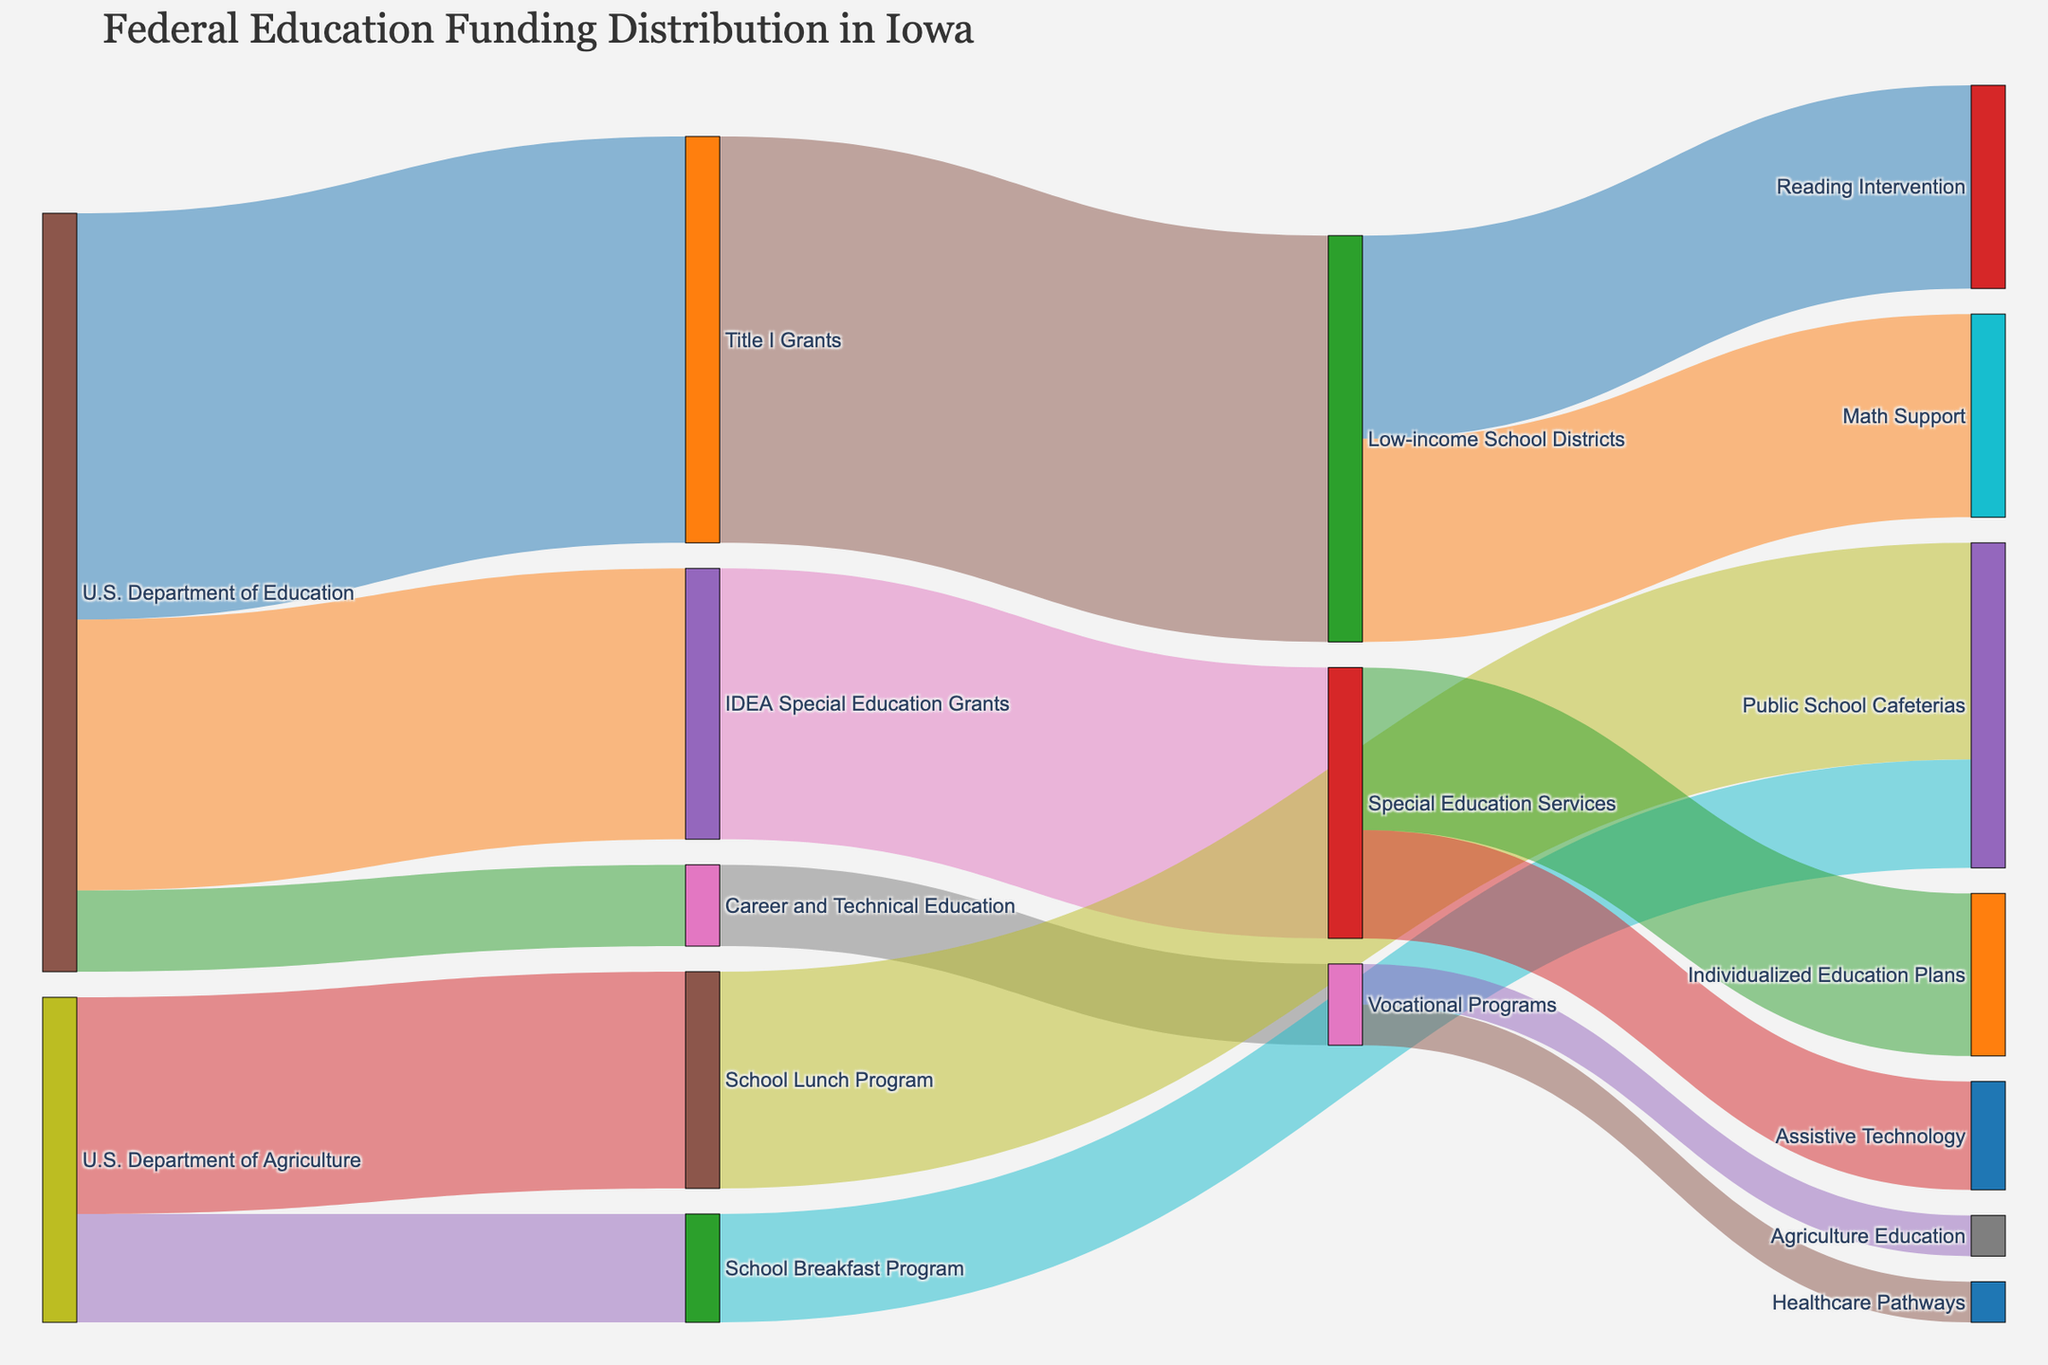What is the largest source of federal education funding in Iowa? By looking at the nodes and the value of funds originating from each federal source, we can see that the U.S. Department of Education has multiple funding streams. The U.S. Department of Education as a source node has the highest total value, which is the sum of the values for Title I Grants, IDEA Special Education Grants, and Career and Technical Education.
Answer: U.S. Department of Education What is the total amount of funding allocated to Public School Cafeterias? To find the total amount allocated to Public School Cafeterias, we should sum the funding from both the School Lunch Program and the School Breakfast Program. The Lunch Program allocates 80,000,000 and the Breakfast Program allocates 40,000,000. Adding these two amounts gives us the total.
Answer: 120,000,000 Which program receives more funding: Special Education Services or Vocational Programs? By examining the values for both target nodes (Special Education Services and Vocational Programs), Special Education Services receives 100,000,000, while Vocational Programs receive 30,000,000. Since 100,000,000 is greater than 30,000,000, Special Education Services receives more funding.
Answer: Special Education Services How is the funding for Low-income School Districts distributed among their activities? The node for Low-income School Districts distributes its funding equally between Reading Intervention and Math Support. Each of these nodes receives 75,000,000.
Answer: Reading Intervention: 75,000,000, Math Support: 75,000,000 Which program receives funding from the U.S. Department of Agriculture? According to the figure, the U.S. Department of Agriculture allocates funding to two programs: the School Lunch Program and the School Breakfast Program.
Answer: School Lunch Program, School Breakfast Program What proportion of the funding from Title I Grants is allocated to Reading Intervention? Title I Grants allocates its total to Low-income School Districts (150,000,000), and Low-income School Districts then allocate 75,000,000 to Reading Intervention. Thus, the proportion is obtained by dividing 75,000,000 by 150,000,000, which yields 0.5 or 50%.
Answer: 50% How much funding does Assistive Technology receive from the IDEA Special Education Grants? IDEA Special Education Grants allocate its funding to Special Education Services. Special Education Services then distribute 40,000,000 to Assistive Technology.
Answer: 40,000,000 Which source provides funding for Vocational Programs? The Sankey Diagram shows that Career and Technical Education, which receives funding from the U.S. Department of Education, provides funding to Vocational Programs.
Answer: Career and Technical Education Out of Healthcare Pathways and Agriculture Education, which one receives more funding and by how much? Both Healthcare Pathways and Agriculture Education receive equal funding from Vocational Programs, each getting 15,000,000. Since both receive the same amount, the difference is zero.
Answer: Neither, the difference is 0 What is the combined funding amount for all categories within the U.S. Department of Education? The funding categories within the U.S. Department of Education are Title I Grants (150,000,000), IDEA Special Education Grants (100,000,000), and Career and Technical Education (30,000,000). Summing these amounts gives 150,000,000 + 100,000,000 + 30,000,000 = 280,000,000.
Answer: 280,000,000 